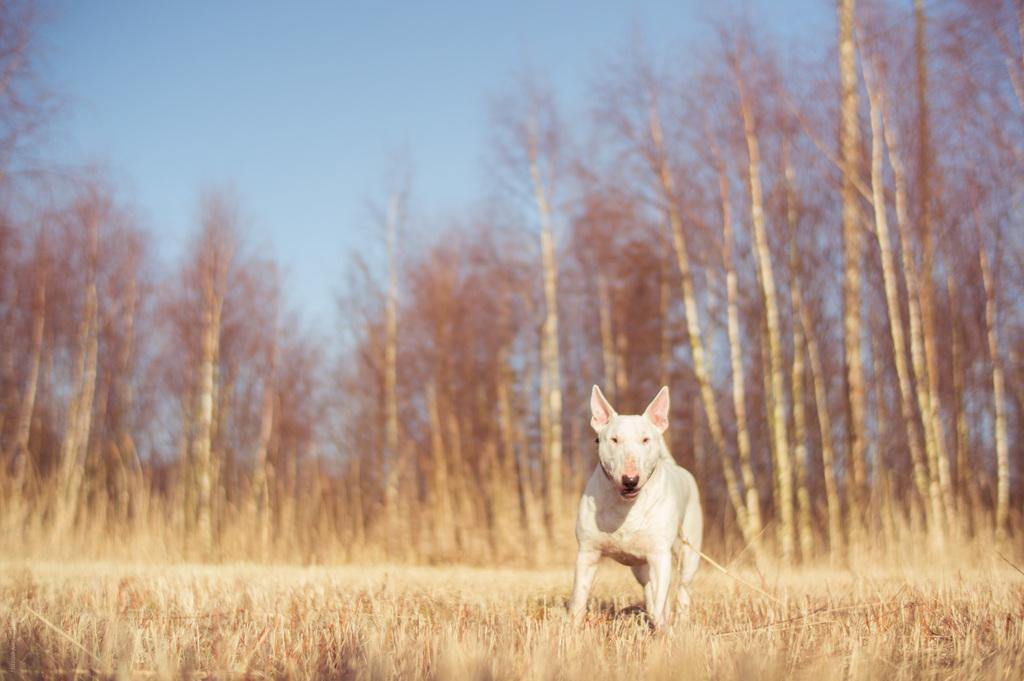What type of animal is in the image? There is a dog in the image. What color is the dog? The dog is white in color. What type of terrain is visible in the image? There is grass visible in the image. What can be seen in the background of the image? There are trees and a blue sky in the background of the image. How many pizzas are being delivered by the dog in the image? There are no pizzas or delivery in the image; it features a white dog in a grassy area with trees and a blue sky in the background. 